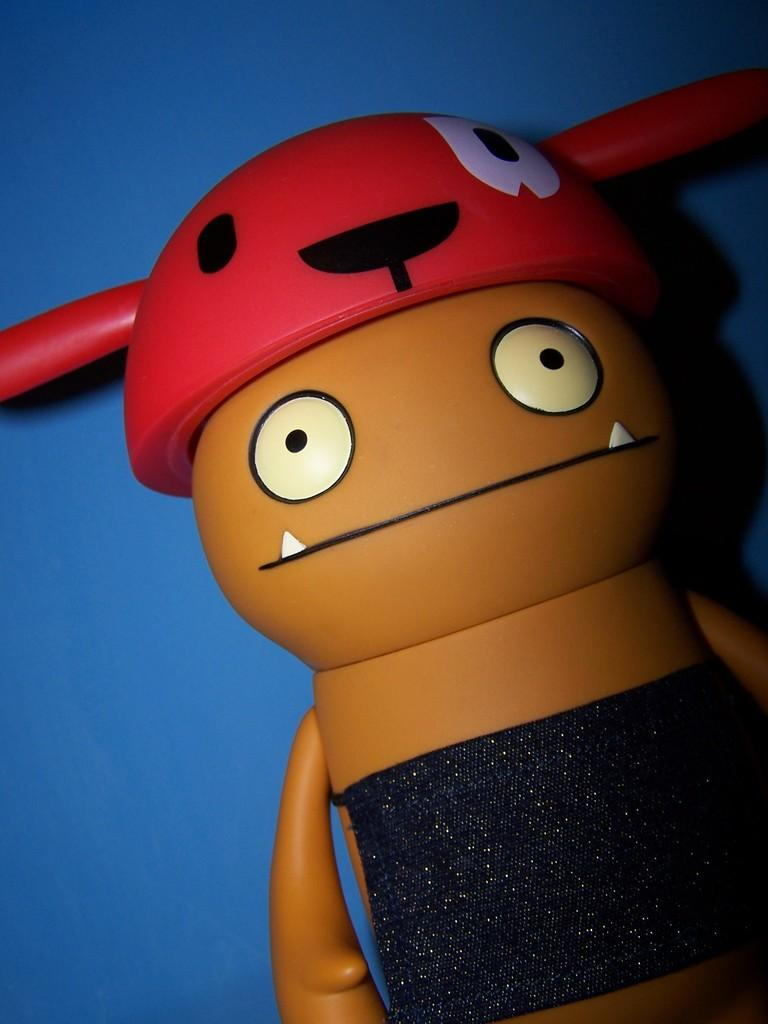What object can be seen in the image? There is a toy in the image. What color is the background of the image? The background of the image is blue. What type of cord is connected to the toy in the image? There is no cord connected to the toy in the image. What knowledge can be gained from the toy in the image? The toy itself does not convey any knowledge; it is an object for play or decoration. 